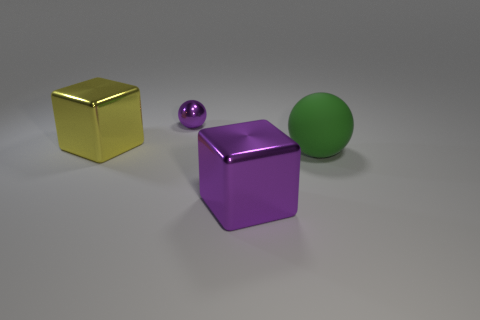There is a thing that is in front of the large green matte ball; does it have the same shape as the large metal object behind the matte ball?
Provide a short and direct response. Yes. The other purple object that is the same shape as the matte object is what size?
Offer a terse response. Small. What number of other small objects have the same material as the yellow thing?
Provide a succinct answer. 1. What is the material of the big green sphere?
Your response must be concise. Rubber. There is a large metal thing right of the ball behind the green thing; what is its shape?
Provide a short and direct response. Cube. There is a tiny purple object behind the rubber ball; what shape is it?
Ensure brevity in your answer.  Sphere. How many blocks have the same color as the metal ball?
Provide a succinct answer. 1. What is the color of the big sphere?
Provide a short and direct response. Green. How many big rubber objects are in front of the purple block right of the purple ball?
Keep it short and to the point. 0. There is a purple ball; is its size the same as the metal block left of the large purple thing?
Make the answer very short. No. 